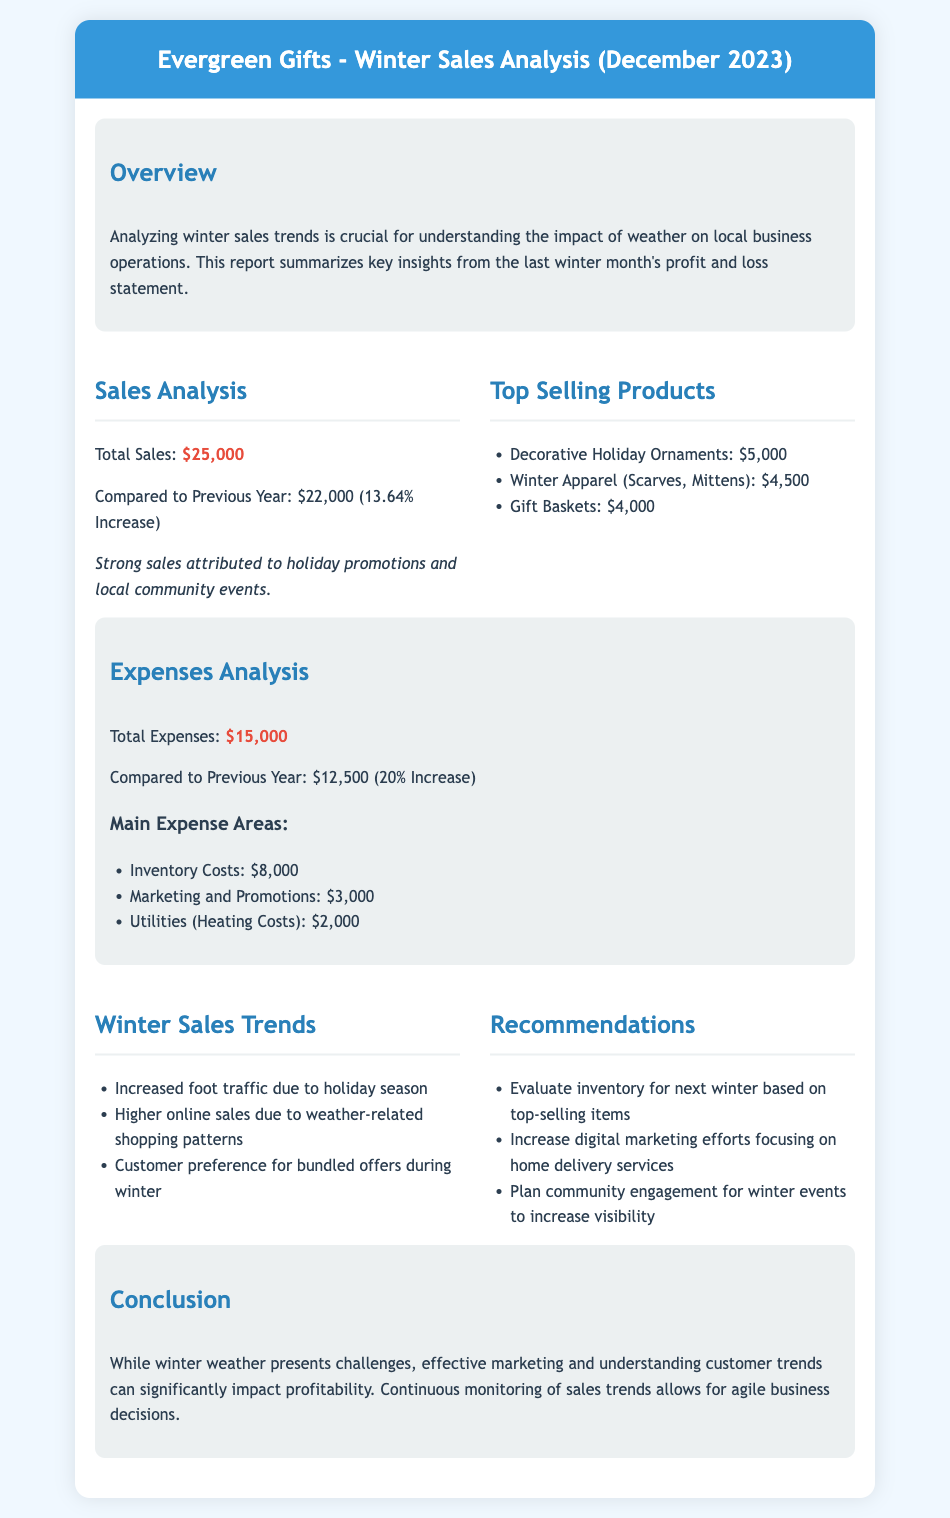What is the total sales for December 2023? The total sales figure is clearly stated in the document as $25,000.
Answer: $25,000 What was the increase in sales compared to the previous year? The document mentions that total sales increased by $3,000 from the previous year, which is a 13.64% increase.
Answer: 13.64% What were the top-selling products? The document lists specific products and their sales figures; the top three products are mentioned.
Answer: Decorative Holiday Ornaments, Winter Apparel, Gift Baskets What was the total expenses amount? The total expenses for the month are provided in the document as $15,000.
Answer: $15,000 What was the percentage increase in expenses compared to the previous year? The document specifies that the expenses increased by 20% from the previous year.
Answer: 20% What are the main areas of expense? The document lists three main expense areas: Inventory Costs, Marketing and Promotions, and Utilities.
Answer: Inventory Costs, Marketing and Promotions, Utilities What is a key trend in winter sales according to the document? The document highlights that increased foot traffic due to the holiday season is a key trend for winter sales.
Answer: Increased foot traffic What is one recommendation for next winter? The document provides several recommendations, one being to evaluate inventory based on top-selling items.
Answer: Evaluate inventory What impact does the document suggest winter weather has on profitability? The conclusion section discusses that effective marketing and understanding customer trends mitigate winter weather challenges.
Answer: Effective marketing 